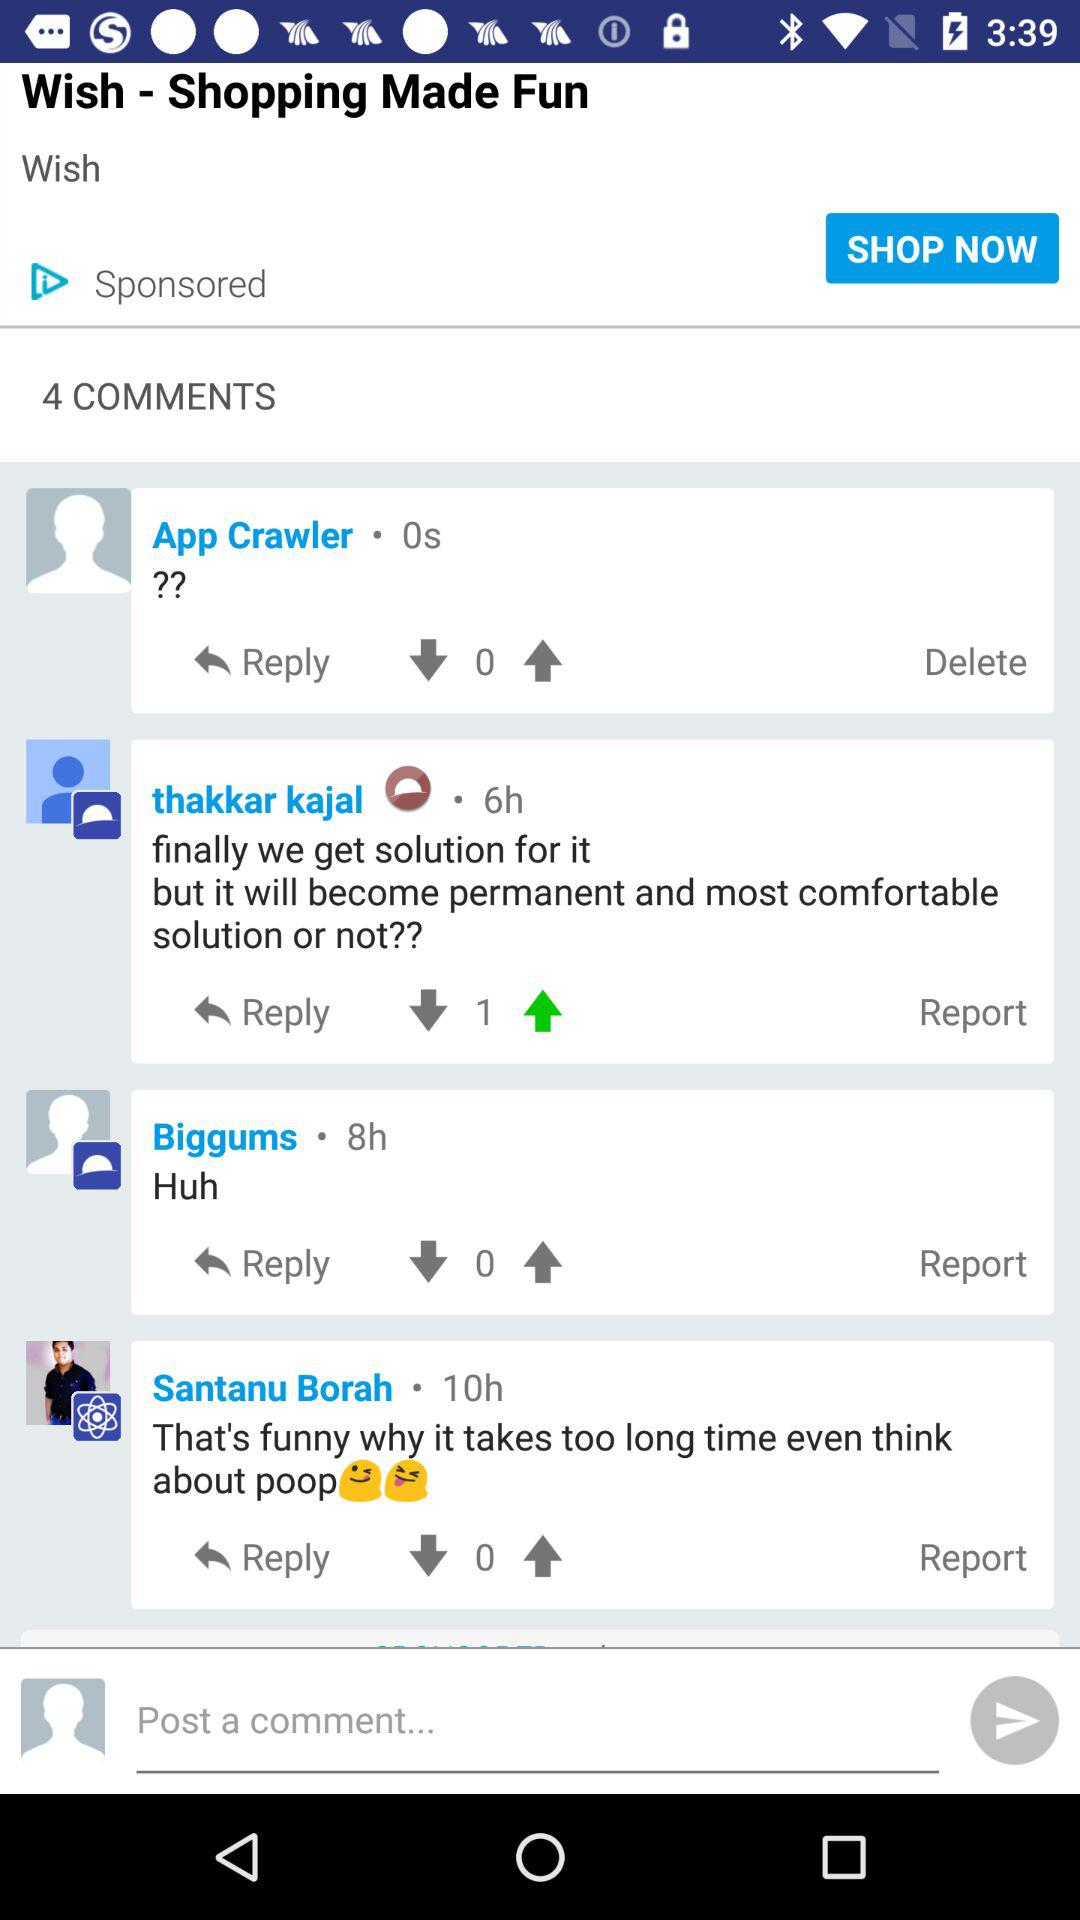How many comments are there?
Answer the question using a single word or phrase. 4 